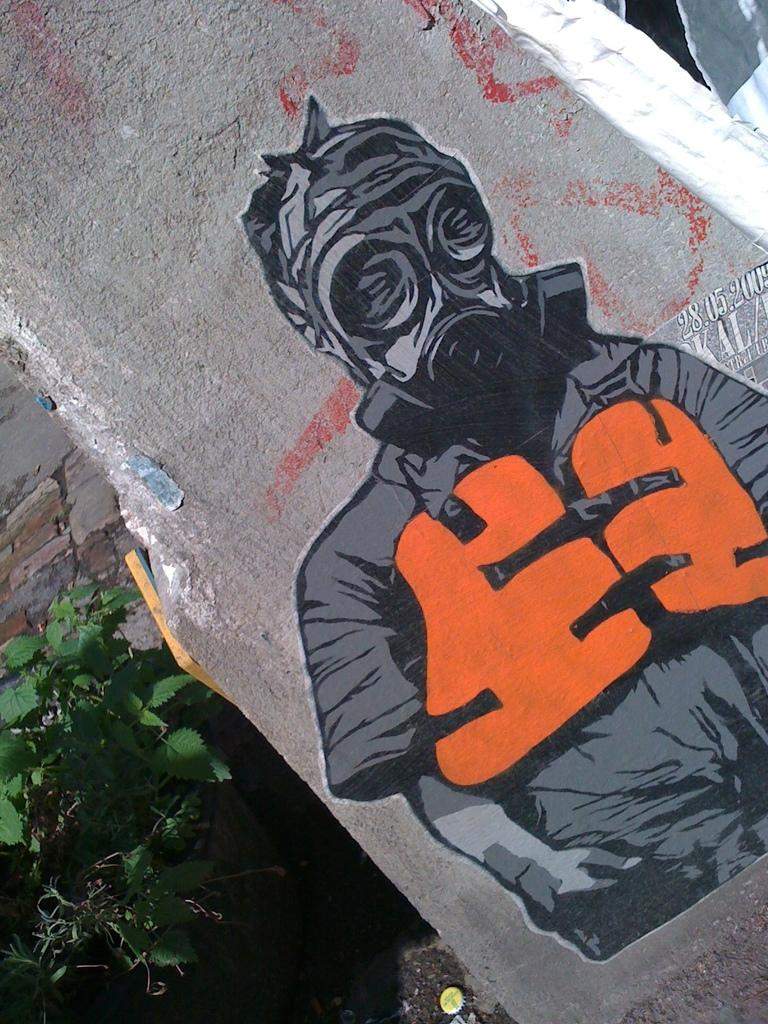What is the main subject of the wall painting in the image? The wall painting depicts a person. What colors are used to paint the person in the wall painting? The person in the painting is in grey and orange colors. What can be seen to the left of the image? There are plants to the left of the image. Can you tell me how many donkeys are present in the wall painting? There are no donkeys depicted in the wall painting; it features a person. What type of ink is used to create the grey and orange colors in the wall painting? The provided facts do not mention the type of ink used in the wall painting, so it cannot be determined from the image. 